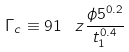Convert formula to latex. <formula><loc_0><loc_0><loc_500><loc_500>\Gamma _ { c } \equiv 9 1 \, \ z \frac { \phi 5 ^ { 0 . 2 } } { t _ { 1 } ^ { 0 . 4 } }</formula> 